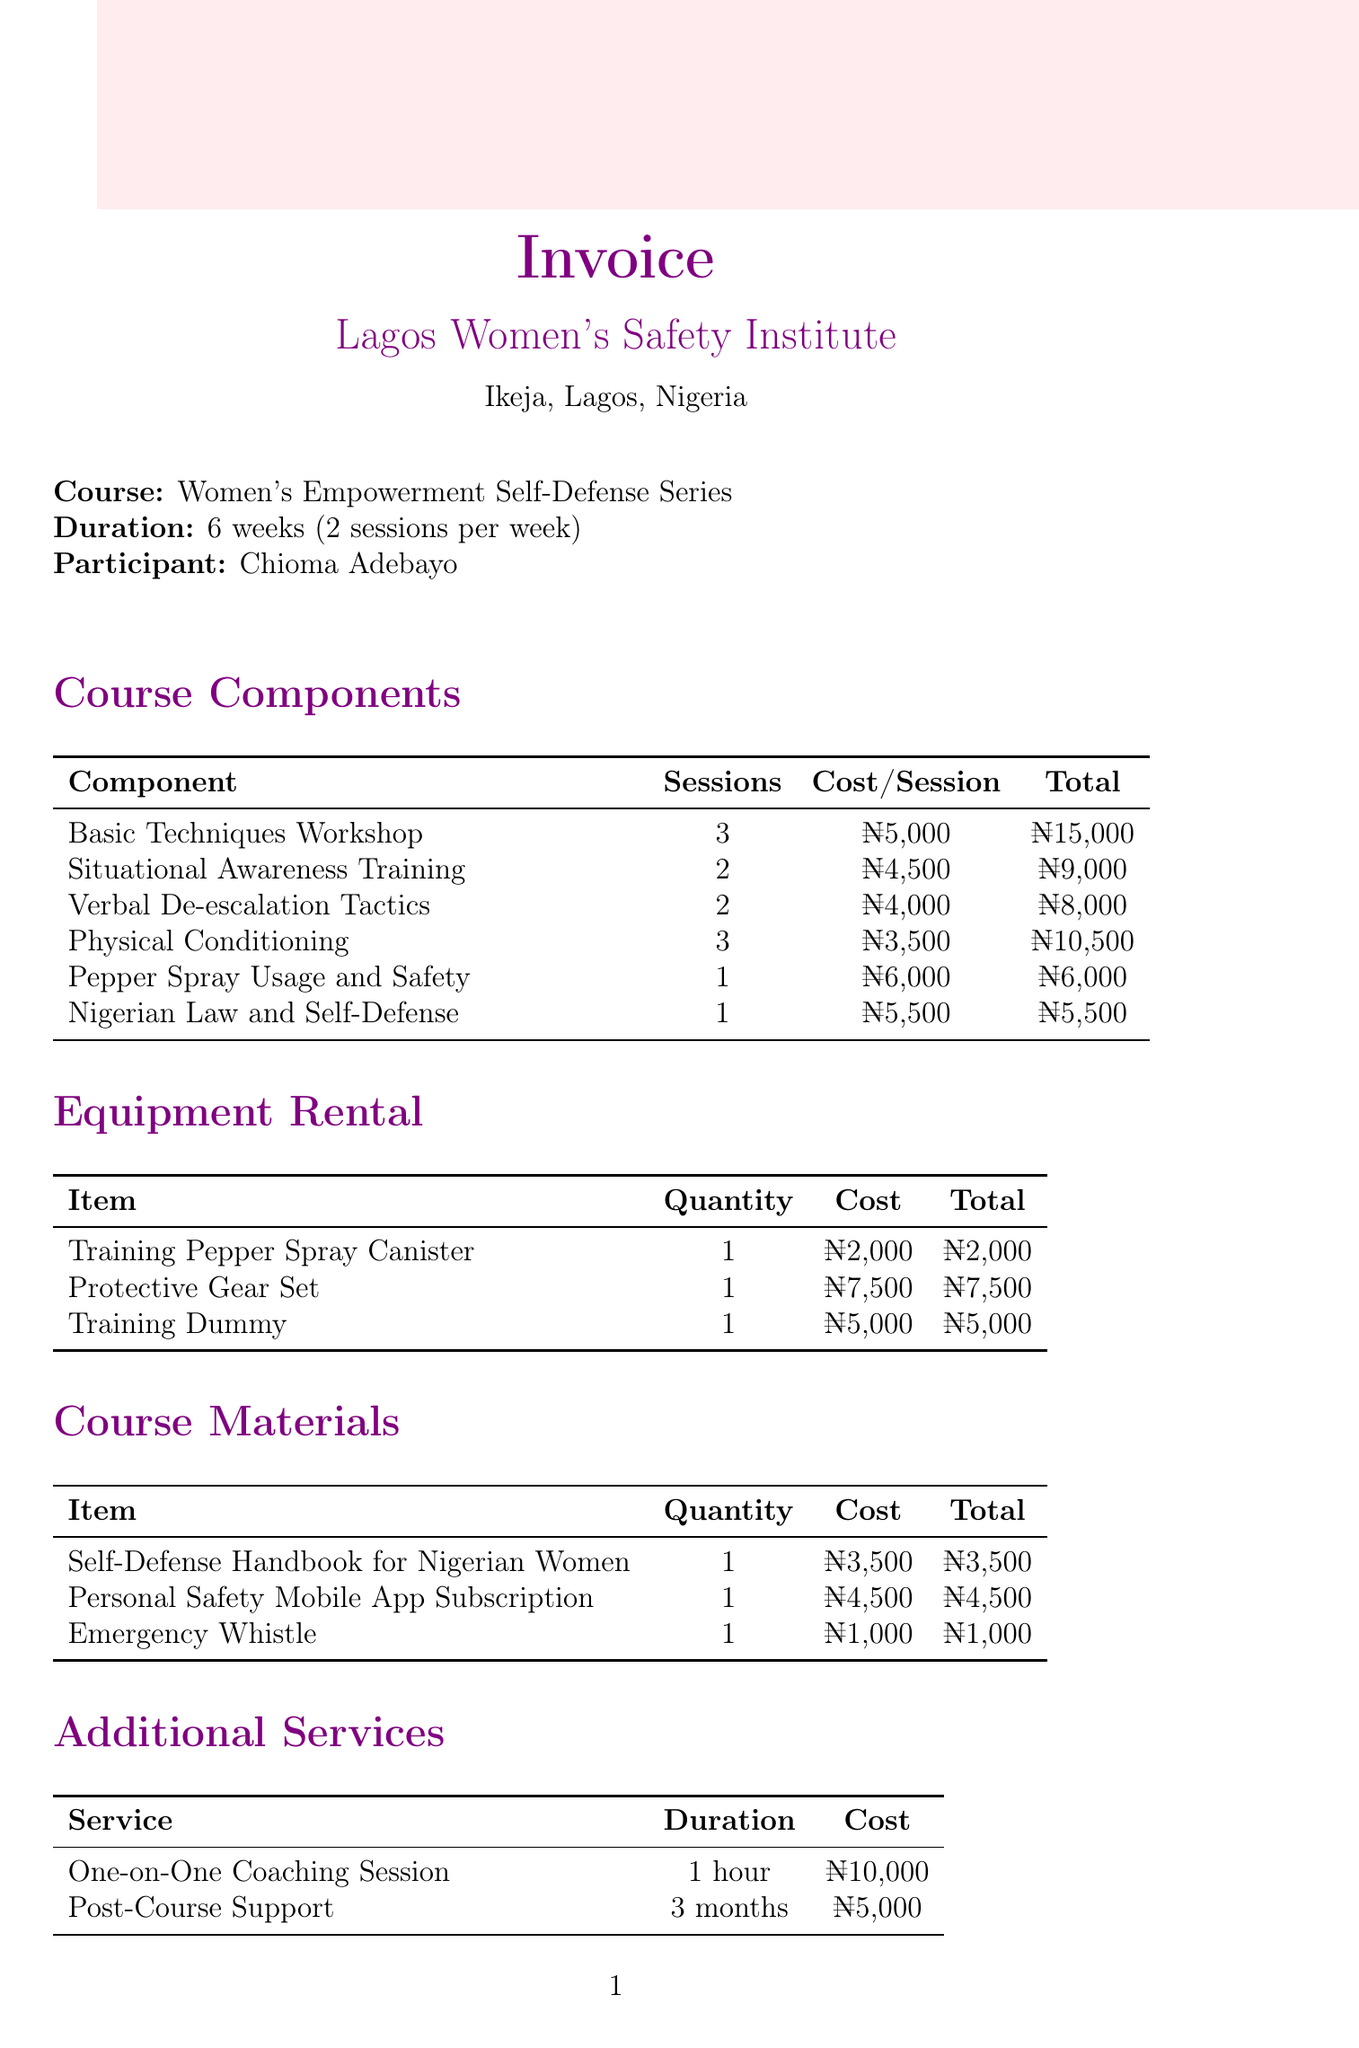What is the course name? The course name is listed at the top of the document as part of the invoice details.
Answer: Women's Empowerment Self-Defense Series Who is the participant? The participant's name is provided in the invoice details section.
Answer: Chioma Adebayo How many sessions are included in the Basic Techniques Workshop? The number of sessions is specified under the course components for Basic Techniques Workshop.
Answer: 3 What is the total cost for the Situational Awareness Training? The total cost is calculated by multiplying the number of sessions by the cost per session for Situational Awareness Training.
Answer: ₦9,000 How much does the Protective Gear Set cost? The cost of the Protective Gear Set is specified in the equipment rental section of the document.
Answer: ₦7,500 What is the total due amount? The total due is indicated at the bottom right of the invoice document as the final payment amount.
Answer: ₦92,500 What item is included in the course materials? The course materials section lists various items, one of which is provided as an example.
Answer: Self-Defense Handbook for Nigerian Women What is the duration of the Post-Course Support service? The duration for Post-Course Support is mentioned in the additional services section.
Answer: 3 months How many sessions does the course last? The duration of the course is noted at the start of the document.
Answer: 6 weeks 